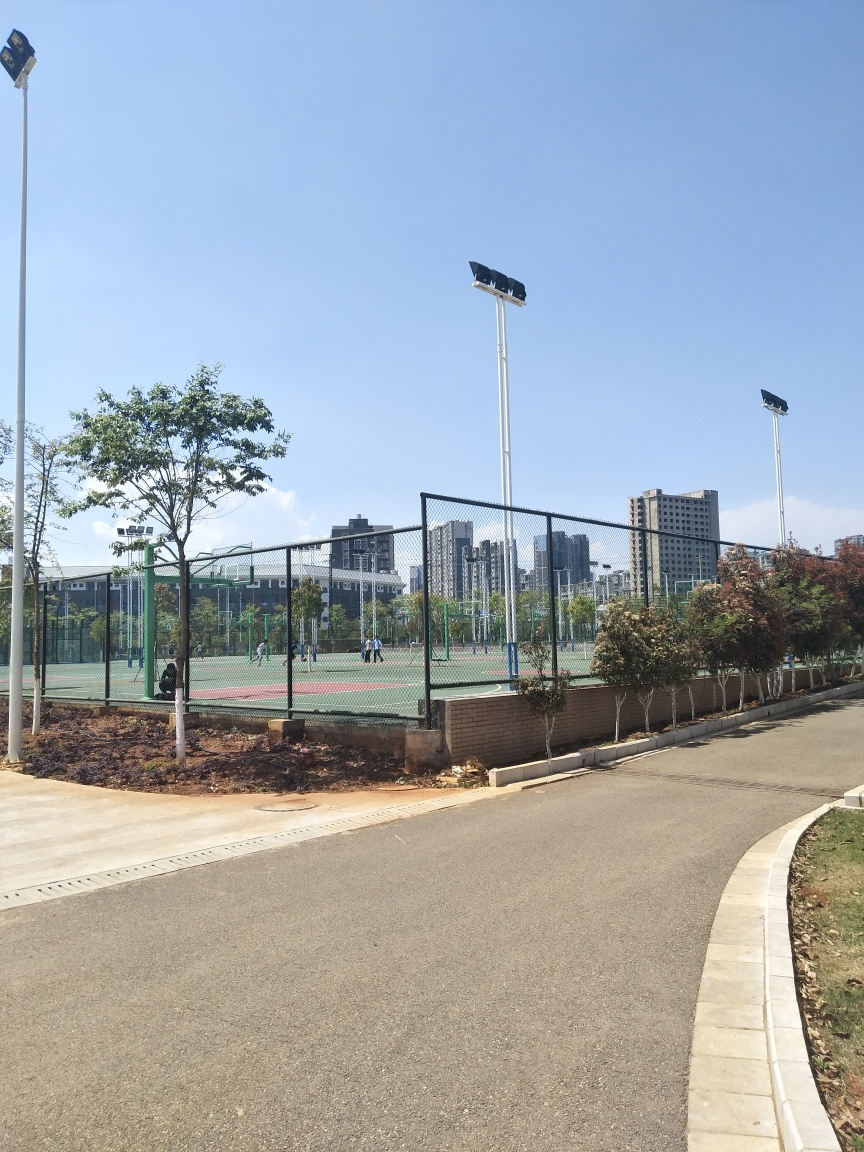Is the area shown in the image seem to be well-maintained? Yes, the park appears well-maintained. The courts are clean, the greenery is neatly trimmed, and the pathway is in good condition without visible litter or damage. 